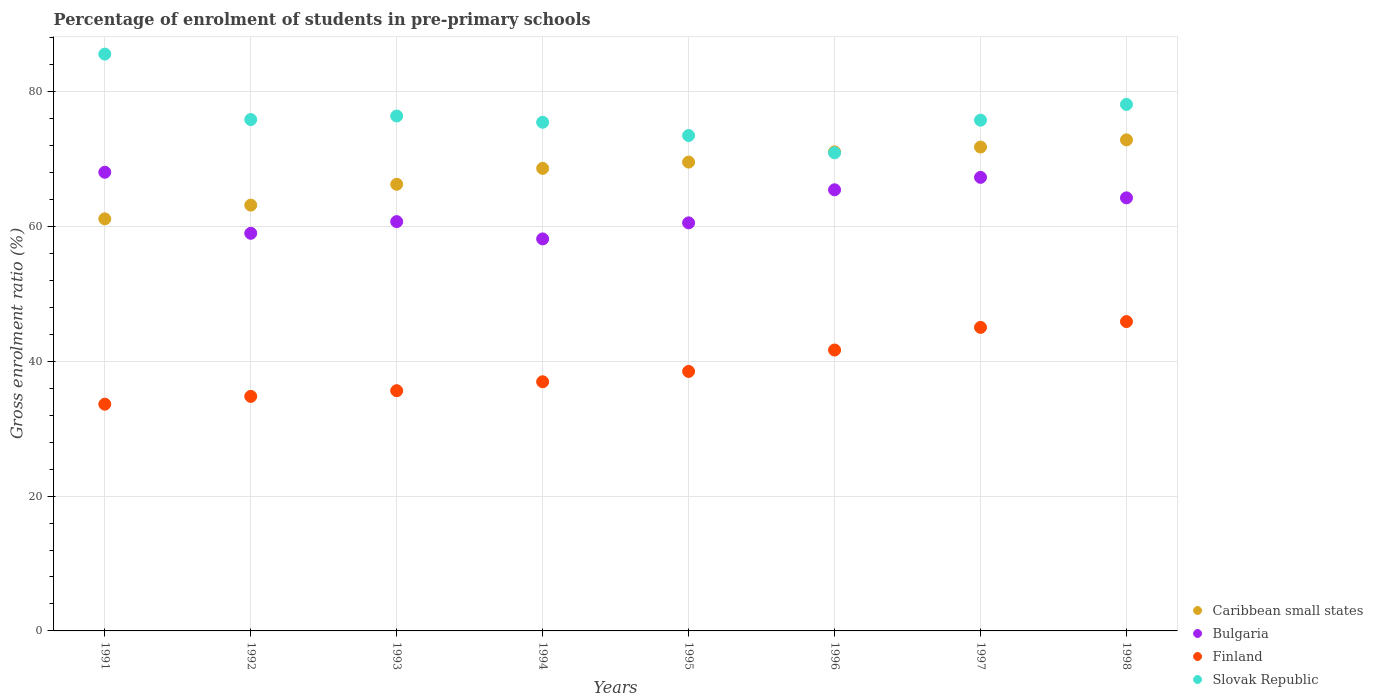How many different coloured dotlines are there?
Offer a very short reply. 4. What is the percentage of students enrolled in pre-primary schools in Finland in 1995?
Ensure brevity in your answer.  38.49. Across all years, what is the maximum percentage of students enrolled in pre-primary schools in Bulgaria?
Keep it short and to the point. 68.03. Across all years, what is the minimum percentage of students enrolled in pre-primary schools in Caribbean small states?
Make the answer very short. 61.12. In which year was the percentage of students enrolled in pre-primary schools in Slovak Republic minimum?
Your answer should be very brief. 1996. What is the total percentage of students enrolled in pre-primary schools in Slovak Republic in the graph?
Make the answer very short. 611.43. What is the difference between the percentage of students enrolled in pre-primary schools in Finland in 1993 and that in 1998?
Provide a short and direct response. -10.25. What is the difference between the percentage of students enrolled in pre-primary schools in Finland in 1993 and the percentage of students enrolled in pre-primary schools in Bulgaria in 1997?
Make the answer very short. -31.64. What is the average percentage of students enrolled in pre-primary schools in Finland per year?
Make the answer very short. 39. In the year 1998, what is the difference between the percentage of students enrolled in pre-primary schools in Caribbean small states and percentage of students enrolled in pre-primary schools in Finland?
Offer a terse response. 26.95. In how many years, is the percentage of students enrolled in pre-primary schools in Finland greater than 36 %?
Give a very brief answer. 5. What is the ratio of the percentage of students enrolled in pre-primary schools in Slovak Republic in 1993 to that in 1995?
Offer a very short reply. 1.04. Is the percentage of students enrolled in pre-primary schools in Bulgaria in 1991 less than that in 1995?
Your answer should be compact. No. What is the difference between the highest and the second highest percentage of students enrolled in pre-primary schools in Caribbean small states?
Ensure brevity in your answer.  1.07. What is the difference between the highest and the lowest percentage of students enrolled in pre-primary schools in Bulgaria?
Ensure brevity in your answer.  9.89. In how many years, is the percentage of students enrolled in pre-primary schools in Slovak Republic greater than the average percentage of students enrolled in pre-primary schools in Slovak Republic taken over all years?
Your answer should be compact. 2. Is the sum of the percentage of students enrolled in pre-primary schools in Bulgaria in 1991 and 1993 greater than the maximum percentage of students enrolled in pre-primary schools in Finland across all years?
Provide a short and direct response. Yes. Is the percentage of students enrolled in pre-primary schools in Finland strictly greater than the percentage of students enrolled in pre-primary schools in Bulgaria over the years?
Offer a very short reply. No. How many dotlines are there?
Provide a succinct answer. 4. How many years are there in the graph?
Offer a very short reply. 8. Does the graph contain any zero values?
Your response must be concise. No. How many legend labels are there?
Provide a succinct answer. 4. What is the title of the graph?
Offer a terse response. Percentage of enrolment of students in pre-primary schools. Does "Angola" appear as one of the legend labels in the graph?
Offer a terse response. No. What is the Gross enrolment ratio (%) in Caribbean small states in 1991?
Ensure brevity in your answer.  61.12. What is the Gross enrolment ratio (%) in Bulgaria in 1991?
Provide a succinct answer. 68.03. What is the Gross enrolment ratio (%) of Finland in 1991?
Ensure brevity in your answer.  33.63. What is the Gross enrolment ratio (%) in Slovak Republic in 1991?
Give a very brief answer. 85.55. What is the Gross enrolment ratio (%) in Caribbean small states in 1992?
Your response must be concise. 63.15. What is the Gross enrolment ratio (%) in Bulgaria in 1992?
Your answer should be compact. 58.97. What is the Gross enrolment ratio (%) in Finland in 1992?
Make the answer very short. 34.78. What is the Gross enrolment ratio (%) in Slovak Republic in 1992?
Ensure brevity in your answer.  75.84. What is the Gross enrolment ratio (%) in Caribbean small states in 1993?
Offer a terse response. 66.24. What is the Gross enrolment ratio (%) in Bulgaria in 1993?
Ensure brevity in your answer.  60.7. What is the Gross enrolment ratio (%) in Finland in 1993?
Ensure brevity in your answer.  35.63. What is the Gross enrolment ratio (%) in Slovak Republic in 1993?
Your answer should be compact. 76.37. What is the Gross enrolment ratio (%) in Caribbean small states in 1994?
Provide a succinct answer. 68.6. What is the Gross enrolment ratio (%) of Bulgaria in 1994?
Offer a very short reply. 58.14. What is the Gross enrolment ratio (%) in Finland in 1994?
Give a very brief answer. 36.95. What is the Gross enrolment ratio (%) in Slovak Republic in 1994?
Provide a succinct answer. 75.44. What is the Gross enrolment ratio (%) of Caribbean small states in 1995?
Your answer should be compact. 69.53. What is the Gross enrolment ratio (%) in Bulgaria in 1995?
Provide a succinct answer. 60.52. What is the Gross enrolment ratio (%) of Finland in 1995?
Make the answer very short. 38.49. What is the Gross enrolment ratio (%) in Slovak Republic in 1995?
Offer a very short reply. 73.47. What is the Gross enrolment ratio (%) in Caribbean small states in 1996?
Ensure brevity in your answer.  71.05. What is the Gross enrolment ratio (%) in Bulgaria in 1996?
Your answer should be compact. 65.42. What is the Gross enrolment ratio (%) in Finland in 1996?
Ensure brevity in your answer.  41.66. What is the Gross enrolment ratio (%) of Slovak Republic in 1996?
Make the answer very short. 70.91. What is the Gross enrolment ratio (%) in Caribbean small states in 1997?
Keep it short and to the point. 71.76. What is the Gross enrolment ratio (%) of Bulgaria in 1997?
Provide a succinct answer. 67.27. What is the Gross enrolment ratio (%) in Finland in 1997?
Your response must be concise. 45.02. What is the Gross enrolment ratio (%) in Slovak Republic in 1997?
Keep it short and to the point. 75.75. What is the Gross enrolment ratio (%) in Caribbean small states in 1998?
Give a very brief answer. 72.83. What is the Gross enrolment ratio (%) of Bulgaria in 1998?
Make the answer very short. 64.23. What is the Gross enrolment ratio (%) of Finland in 1998?
Your answer should be compact. 45.88. What is the Gross enrolment ratio (%) of Slovak Republic in 1998?
Your answer should be compact. 78.09. Across all years, what is the maximum Gross enrolment ratio (%) in Caribbean small states?
Give a very brief answer. 72.83. Across all years, what is the maximum Gross enrolment ratio (%) of Bulgaria?
Provide a succinct answer. 68.03. Across all years, what is the maximum Gross enrolment ratio (%) of Finland?
Provide a succinct answer. 45.88. Across all years, what is the maximum Gross enrolment ratio (%) of Slovak Republic?
Your response must be concise. 85.55. Across all years, what is the minimum Gross enrolment ratio (%) in Caribbean small states?
Offer a terse response. 61.12. Across all years, what is the minimum Gross enrolment ratio (%) of Bulgaria?
Ensure brevity in your answer.  58.14. Across all years, what is the minimum Gross enrolment ratio (%) of Finland?
Offer a very short reply. 33.63. Across all years, what is the minimum Gross enrolment ratio (%) in Slovak Republic?
Ensure brevity in your answer.  70.91. What is the total Gross enrolment ratio (%) of Caribbean small states in the graph?
Ensure brevity in your answer.  544.28. What is the total Gross enrolment ratio (%) of Bulgaria in the graph?
Give a very brief answer. 503.28. What is the total Gross enrolment ratio (%) of Finland in the graph?
Keep it short and to the point. 312.04. What is the total Gross enrolment ratio (%) in Slovak Republic in the graph?
Provide a short and direct response. 611.43. What is the difference between the Gross enrolment ratio (%) in Caribbean small states in 1991 and that in 1992?
Ensure brevity in your answer.  -2.04. What is the difference between the Gross enrolment ratio (%) of Bulgaria in 1991 and that in 1992?
Provide a succinct answer. 9.05. What is the difference between the Gross enrolment ratio (%) of Finland in 1991 and that in 1992?
Your answer should be very brief. -1.16. What is the difference between the Gross enrolment ratio (%) of Slovak Republic in 1991 and that in 1992?
Offer a terse response. 9.71. What is the difference between the Gross enrolment ratio (%) of Caribbean small states in 1991 and that in 1993?
Provide a short and direct response. -5.13. What is the difference between the Gross enrolment ratio (%) of Bulgaria in 1991 and that in 1993?
Offer a terse response. 7.32. What is the difference between the Gross enrolment ratio (%) in Finland in 1991 and that in 1993?
Provide a succinct answer. -2. What is the difference between the Gross enrolment ratio (%) of Slovak Republic in 1991 and that in 1993?
Make the answer very short. 9.18. What is the difference between the Gross enrolment ratio (%) in Caribbean small states in 1991 and that in 1994?
Provide a short and direct response. -7.48. What is the difference between the Gross enrolment ratio (%) in Bulgaria in 1991 and that in 1994?
Make the answer very short. 9.89. What is the difference between the Gross enrolment ratio (%) in Finland in 1991 and that in 1994?
Offer a terse response. -3.32. What is the difference between the Gross enrolment ratio (%) of Slovak Republic in 1991 and that in 1994?
Your answer should be very brief. 10.11. What is the difference between the Gross enrolment ratio (%) in Caribbean small states in 1991 and that in 1995?
Keep it short and to the point. -8.42. What is the difference between the Gross enrolment ratio (%) of Bulgaria in 1991 and that in 1995?
Provide a succinct answer. 7.51. What is the difference between the Gross enrolment ratio (%) of Finland in 1991 and that in 1995?
Offer a terse response. -4.86. What is the difference between the Gross enrolment ratio (%) of Slovak Republic in 1991 and that in 1995?
Give a very brief answer. 12.08. What is the difference between the Gross enrolment ratio (%) in Caribbean small states in 1991 and that in 1996?
Keep it short and to the point. -9.93. What is the difference between the Gross enrolment ratio (%) in Bulgaria in 1991 and that in 1996?
Provide a short and direct response. 2.6. What is the difference between the Gross enrolment ratio (%) of Finland in 1991 and that in 1996?
Your answer should be very brief. -8.03. What is the difference between the Gross enrolment ratio (%) in Slovak Republic in 1991 and that in 1996?
Offer a terse response. 14.64. What is the difference between the Gross enrolment ratio (%) of Caribbean small states in 1991 and that in 1997?
Keep it short and to the point. -10.65. What is the difference between the Gross enrolment ratio (%) of Bulgaria in 1991 and that in 1997?
Offer a terse response. 0.76. What is the difference between the Gross enrolment ratio (%) in Finland in 1991 and that in 1997?
Provide a short and direct response. -11.39. What is the difference between the Gross enrolment ratio (%) of Slovak Republic in 1991 and that in 1997?
Your response must be concise. 9.8. What is the difference between the Gross enrolment ratio (%) in Caribbean small states in 1991 and that in 1998?
Provide a succinct answer. -11.71. What is the difference between the Gross enrolment ratio (%) in Bulgaria in 1991 and that in 1998?
Your answer should be compact. 3.8. What is the difference between the Gross enrolment ratio (%) of Finland in 1991 and that in 1998?
Give a very brief answer. -12.25. What is the difference between the Gross enrolment ratio (%) in Slovak Republic in 1991 and that in 1998?
Offer a terse response. 7.47. What is the difference between the Gross enrolment ratio (%) of Caribbean small states in 1992 and that in 1993?
Offer a terse response. -3.09. What is the difference between the Gross enrolment ratio (%) of Bulgaria in 1992 and that in 1993?
Make the answer very short. -1.73. What is the difference between the Gross enrolment ratio (%) of Finland in 1992 and that in 1993?
Make the answer very short. -0.84. What is the difference between the Gross enrolment ratio (%) of Slovak Republic in 1992 and that in 1993?
Make the answer very short. -0.53. What is the difference between the Gross enrolment ratio (%) in Caribbean small states in 1992 and that in 1994?
Offer a very short reply. -5.45. What is the difference between the Gross enrolment ratio (%) of Bulgaria in 1992 and that in 1994?
Your response must be concise. 0.83. What is the difference between the Gross enrolment ratio (%) of Finland in 1992 and that in 1994?
Ensure brevity in your answer.  -2.17. What is the difference between the Gross enrolment ratio (%) of Slovak Republic in 1992 and that in 1994?
Your answer should be compact. 0.4. What is the difference between the Gross enrolment ratio (%) in Caribbean small states in 1992 and that in 1995?
Your answer should be very brief. -6.38. What is the difference between the Gross enrolment ratio (%) of Bulgaria in 1992 and that in 1995?
Your answer should be compact. -1.55. What is the difference between the Gross enrolment ratio (%) of Finland in 1992 and that in 1995?
Offer a very short reply. -3.7. What is the difference between the Gross enrolment ratio (%) in Slovak Republic in 1992 and that in 1995?
Ensure brevity in your answer.  2.37. What is the difference between the Gross enrolment ratio (%) in Caribbean small states in 1992 and that in 1996?
Keep it short and to the point. -7.9. What is the difference between the Gross enrolment ratio (%) of Bulgaria in 1992 and that in 1996?
Your response must be concise. -6.45. What is the difference between the Gross enrolment ratio (%) of Finland in 1992 and that in 1996?
Provide a short and direct response. -6.88. What is the difference between the Gross enrolment ratio (%) of Slovak Republic in 1992 and that in 1996?
Keep it short and to the point. 4.93. What is the difference between the Gross enrolment ratio (%) in Caribbean small states in 1992 and that in 1997?
Give a very brief answer. -8.61. What is the difference between the Gross enrolment ratio (%) in Bulgaria in 1992 and that in 1997?
Make the answer very short. -8.3. What is the difference between the Gross enrolment ratio (%) of Finland in 1992 and that in 1997?
Make the answer very short. -10.23. What is the difference between the Gross enrolment ratio (%) in Slovak Republic in 1992 and that in 1997?
Your response must be concise. 0.09. What is the difference between the Gross enrolment ratio (%) of Caribbean small states in 1992 and that in 1998?
Your answer should be very brief. -9.68. What is the difference between the Gross enrolment ratio (%) of Bulgaria in 1992 and that in 1998?
Your answer should be very brief. -5.26. What is the difference between the Gross enrolment ratio (%) of Finland in 1992 and that in 1998?
Provide a short and direct response. -11.09. What is the difference between the Gross enrolment ratio (%) in Slovak Republic in 1992 and that in 1998?
Provide a succinct answer. -2.25. What is the difference between the Gross enrolment ratio (%) of Caribbean small states in 1993 and that in 1994?
Provide a short and direct response. -2.36. What is the difference between the Gross enrolment ratio (%) of Bulgaria in 1993 and that in 1994?
Keep it short and to the point. 2.57. What is the difference between the Gross enrolment ratio (%) in Finland in 1993 and that in 1994?
Offer a terse response. -1.32. What is the difference between the Gross enrolment ratio (%) in Caribbean small states in 1993 and that in 1995?
Provide a succinct answer. -3.29. What is the difference between the Gross enrolment ratio (%) in Bulgaria in 1993 and that in 1995?
Provide a succinct answer. 0.18. What is the difference between the Gross enrolment ratio (%) of Finland in 1993 and that in 1995?
Offer a very short reply. -2.86. What is the difference between the Gross enrolment ratio (%) of Slovak Republic in 1993 and that in 1995?
Provide a short and direct response. 2.89. What is the difference between the Gross enrolment ratio (%) of Caribbean small states in 1993 and that in 1996?
Ensure brevity in your answer.  -4.81. What is the difference between the Gross enrolment ratio (%) of Bulgaria in 1993 and that in 1996?
Your answer should be compact. -4.72. What is the difference between the Gross enrolment ratio (%) in Finland in 1993 and that in 1996?
Your response must be concise. -6.03. What is the difference between the Gross enrolment ratio (%) in Slovak Republic in 1993 and that in 1996?
Your answer should be compact. 5.46. What is the difference between the Gross enrolment ratio (%) of Caribbean small states in 1993 and that in 1997?
Give a very brief answer. -5.52. What is the difference between the Gross enrolment ratio (%) of Bulgaria in 1993 and that in 1997?
Provide a short and direct response. -6.56. What is the difference between the Gross enrolment ratio (%) of Finland in 1993 and that in 1997?
Offer a terse response. -9.39. What is the difference between the Gross enrolment ratio (%) in Slovak Republic in 1993 and that in 1997?
Give a very brief answer. 0.62. What is the difference between the Gross enrolment ratio (%) of Caribbean small states in 1993 and that in 1998?
Ensure brevity in your answer.  -6.59. What is the difference between the Gross enrolment ratio (%) in Bulgaria in 1993 and that in 1998?
Keep it short and to the point. -3.52. What is the difference between the Gross enrolment ratio (%) of Finland in 1993 and that in 1998?
Your answer should be compact. -10.25. What is the difference between the Gross enrolment ratio (%) of Slovak Republic in 1993 and that in 1998?
Your answer should be very brief. -1.72. What is the difference between the Gross enrolment ratio (%) of Caribbean small states in 1994 and that in 1995?
Your answer should be very brief. -0.93. What is the difference between the Gross enrolment ratio (%) of Bulgaria in 1994 and that in 1995?
Your response must be concise. -2.38. What is the difference between the Gross enrolment ratio (%) in Finland in 1994 and that in 1995?
Offer a very short reply. -1.54. What is the difference between the Gross enrolment ratio (%) of Slovak Republic in 1994 and that in 1995?
Make the answer very short. 1.96. What is the difference between the Gross enrolment ratio (%) in Caribbean small states in 1994 and that in 1996?
Your response must be concise. -2.45. What is the difference between the Gross enrolment ratio (%) of Bulgaria in 1994 and that in 1996?
Ensure brevity in your answer.  -7.28. What is the difference between the Gross enrolment ratio (%) in Finland in 1994 and that in 1996?
Give a very brief answer. -4.71. What is the difference between the Gross enrolment ratio (%) of Slovak Republic in 1994 and that in 1996?
Provide a succinct answer. 4.53. What is the difference between the Gross enrolment ratio (%) of Caribbean small states in 1994 and that in 1997?
Offer a terse response. -3.16. What is the difference between the Gross enrolment ratio (%) of Bulgaria in 1994 and that in 1997?
Give a very brief answer. -9.13. What is the difference between the Gross enrolment ratio (%) of Finland in 1994 and that in 1997?
Provide a short and direct response. -8.07. What is the difference between the Gross enrolment ratio (%) of Slovak Republic in 1994 and that in 1997?
Offer a terse response. -0.31. What is the difference between the Gross enrolment ratio (%) in Caribbean small states in 1994 and that in 1998?
Provide a short and direct response. -4.23. What is the difference between the Gross enrolment ratio (%) of Bulgaria in 1994 and that in 1998?
Give a very brief answer. -6.09. What is the difference between the Gross enrolment ratio (%) of Finland in 1994 and that in 1998?
Give a very brief answer. -8.93. What is the difference between the Gross enrolment ratio (%) in Slovak Republic in 1994 and that in 1998?
Ensure brevity in your answer.  -2.65. What is the difference between the Gross enrolment ratio (%) of Caribbean small states in 1995 and that in 1996?
Provide a succinct answer. -1.51. What is the difference between the Gross enrolment ratio (%) of Bulgaria in 1995 and that in 1996?
Give a very brief answer. -4.9. What is the difference between the Gross enrolment ratio (%) in Finland in 1995 and that in 1996?
Ensure brevity in your answer.  -3.17. What is the difference between the Gross enrolment ratio (%) of Slovak Republic in 1995 and that in 1996?
Your answer should be compact. 2.56. What is the difference between the Gross enrolment ratio (%) of Caribbean small states in 1995 and that in 1997?
Offer a terse response. -2.23. What is the difference between the Gross enrolment ratio (%) of Bulgaria in 1995 and that in 1997?
Your answer should be very brief. -6.75. What is the difference between the Gross enrolment ratio (%) of Finland in 1995 and that in 1997?
Your answer should be very brief. -6.53. What is the difference between the Gross enrolment ratio (%) of Slovak Republic in 1995 and that in 1997?
Keep it short and to the point. -2.28. What is the difference between the Gross enrolment ratio (%) of Caribbean small states in 1995 and that in 1998?
Your answer should be compact. -3.29. What is the difference between the Gross enrolment ratio (%) in Bulgaria in 1995 and that in 1998?
Provide a short and direct response. -3.71. What is the difference between the Gross enrolment ratio (%) in Finland in 1995 and that in 1998?
Provide a succinct answer. -7.39. What is the difference between the Gross enrolment ratio (%) of Slovak Republic in 1995 and that in 1998?
Provide a short and direct response. -4.61. What is the difference between the Gross enrolment ratio (%) in Caribbean small states in 1996 and that in 1997?
Offer a very short reply. -0.72. What is the difference between the Gross enrolment ratio (%) of Bulgaria in 1996 and that in 1997?
Provide a short and direct response. -1.85. What is the difference between the Gross enrolment ratio (%) in Finland in 1996 and that in 1997?
Your response must be concise. -3.36. What is the difference between the Gross enrolment ratio (%) in Slovak Republic in 1996 and that in 1997?
Your answer should be compact. -4.84. What is the difference between the Gross enrolment ratio (%) in Caribbean small states in 1996 and that in 1998?
Give a very brief answer. -1.78. What is the difference between the Gross enrolment ratio (%) in Bulgaria in 1996 and that in 1998?
Give a very brief answer. 1.2. What is the difference between the Gross enrolment ratio (%) in Finland in 1996 and that in 1998?
Keep it short and to the point. -4.22. What is the difference between the Gross enrolment ratio (%) in Slovak Republic in 1996 and that in 1998?
Your answer should be compact. -7.18. What is the difference between the Gross enrolment ratio (%) of Caribbean small states in 1997 and that in 1998?
Keep it short and to the point. -1.07. What is the difference between the Gross enrolment ratio (%) of Bulgaria in 1997 and that in 1998?
Provide a short and direct response. 3.04. What is the difference between the Gross enrolment ratio (%) of Finland in 1997 and that in 1998?
Keep it short and to the point. -0.86. What is the difference between the Gross enrolment ratio (%) of Slovak Republic in 1997 and that in 1998?
Your answer should be compact. -2.34. What is the difference between the Gross enrolment ratio (%) of Caribbean small states in 1991 and the Gross enrolment ratio (%) of Bulgaria in 1992?
Provide a short and direct response. 2.14. What is the difference between the Gross enrolment ratio (%) in Caribbean small states in 1991 and the Gross enrolment ratio (%) in Finland in 1992?
Ensure brevity in your answer.  26.33. What is the difference between the Gross enrolment ratio (%) of Caribbean small states in 1991 and the Gross enrolment ratio (%) of Slovak Republic in 1992?
Your answer should be compact. -14.73. What is the difference between the Gross enrolment ratio (%) in Bulgaria in 1991 and the Gross enrolment ratio (%) in Finland in 1992?
Offer a terse response. 33.24. What is the difference between the Gross enrolment ratio (%) of Bulgaria in 1991 and the Gross enrolment ratio (%) of Slovak Republic in 1992?
Provide a succinct answer. -7.82. What is the difference between the Gross enrolment ratio (%) in Finland in 1991 and the Gross enrolment ratio (%) in Slovak Republic in 1992?
Keep it short and to the point. -42.21. What is the difference between the Gross enrolment ratio (%) in Caribbean small states in 1991 and the Gross enrolment ratio (%) in Bulgaria in 1993?
Provide a succinct answer. 0.41. What is the difference between the Gross enrolment ratio (%) of Caribbean small states in 1991 and the Gross enrolment ratio (%) of Finland in 1993?
Keep it short and to the point. 25.49. What is the difference between the Gross enrolment ratio (%) of Caribbean small states in 1991 and the Gross enrolment ratio (%) of Slovak Republic in 1993?
Offer a very short reply. -15.25. What is the difference between the Gross enrolment ratio (%) in Bulgaria in 1991 and the Gross enrolment ratio (%) in Finland in 1993?
Provide a succinct answer. 32.4. What is the difference between the Gross enrolment ratio (%) of Bulgaria in 1991 and the Gross enrolment ratio (%) of Slovak Republic in 1993?
Your answer should be very brief. -8.34. What is the difference between the Gross enrolment ratio (%) in Finland in 1991 and the Gross enrolment ratio (%) in Slovak Republic in 1993?
Provide a short and direct response. -42.74. What is the difference between the Gross enrolment ratio (%) of Caribbean small states in 1991 and the Gross enrolment ratio (%) of Bulgaria in 1994?
Your answer should be very brief. 2.98. What is the difference between the Gross enrolment ratio (%) in Caribbean small states in 1991 and the Gross enrolment ratio (%) in Finland in 1994?
Your answer should be very brief. 24.16. What is the difference between the Gross enrolment ratio (%) in Caribbean small states in 1991 and the Gross enrolment ratio (%) in Slovak Republic in 1994?
Give a very brief answer. -14.32. What is the difference between the Gross enrolment ratio (%) of Bulgaria in 1991 and the Gross enrolment ratio (%) of Finland in 1994?
Keep it short and to the point. 31.07. What is the difference between the Gross enrolment ratio (%) of Bulgaria in 1991 and the Gross enrolment ratio (%) of Slovak Republic in 1994?
Offer a terse response. -7.41. What is the difference between the Gross enrolment ratio (%) in Finland in 1991 and the Gross enrolment ratio (%) in Slovak Republic in 1994?
Your response must be concise. -41.81. What is the difference between the Gross enrolment ratio (%) in Caribbean small states in 1991 and the Gross enrolment ratio (%) in Bulgaria in 1995?
Give a very brief answer. 0.6. What is the difference between the Gross enrolment ratio (%) of Caribbean small states in 1991 and the Gross enrolment ratio (%) of Finland in 1995?
Provide a short and direct response. 22.63. What is the difference between the Gross enrolment ratio (%) of Caribbean small states in 1991 and the Gross enrolment ratio (%) of Slovak Republic in 1995?
Keep it short and to the point. -12.36. What is the difference between the Gross enrolment ratio (%) of Bulgaria in 1991 and the Gross enrolment ratio (%) of Finland in 1995?
Keep it short and to the point. 29.54. What is the difference between the Gross enrolment ratio (%) of Bulgaria in 1991 and the Gross enrolment ratio (%) of Slovak Republic in 1995?
Offer a terse response. -5.45. What is the difference between the Gross enrolment ratio (%) of Finland in 1991 and the Gross enrolment ratio (%) of Slovak Republic in 1995?
Ensure brevity in your answer.  -39.85. What is the difference between the Gross enrolment ratio (%) of Caribbean small states in 1991 and the Gross enrolment ratio (%) of Bulgaria in 1996?
Your answer should be very brief. -4.31. What is the difference between the Gross enrolment ratio (%) in Caribbean small states in 1991 and the Gross enrolment ratio (%) in Finland in 1996?
Make the answer very short. 19.46. What is the difference between the Gross enrolment ratio (%) in Caribbean small states in 1991 and the Gross enrolment ratio (%) in Slovak Republic in 1996?
Give a very brief answer. -9.79. What is the difference between the Gross enrolment ratio (%) in Bulgaria in 1991 and the Gross enrolment ratio (%) in Finland in 1996?
Give a very brief answer. 26.37. What is the difference between the Gross enrolment ratio (%) of Bulgaria in 1991 and the Gross enrolment ratio (%) of Slovak Republic in 1996?
Your response must be concise. -2.88. What is the difference between the Gross enrolment ratio (%) of Finland in 1991 and the Gross enrolment ratio (%) of Slovak Republic in 1996?
Keep it short and to the point. -37.28. What is the difference between the Gross enrolment ratio (%) of Caribbean small states in 1991 and the Gross enrolment ratio (%) of Bulgaria in 1997?
Provide a short and direct response. -6.15. What is the difference between the Gross enrolment ratio (%) in Caribbean small states in 1991 and the Gross enrolment ratio (%) in Finland in 1997?
Provide a succinct answer. 16.1. What is the difference between the Gross enrolment ratio (%) of Caribbean small states in 1991 and the Gross enrolment ratio (%) of Slovak Republic in 1997?
Offer a very short reply. -14.64. What is the difference between the Gross enrolment ratio (%) of Bulgaria in 1991 and the Gross enrolment ratio (%) of Finland in 1997?
Your answer should be compact. 23.01. What is the difference between the Gross enrolment ratio (%) of Bulgaria in 1991 and the Gross enrolment ratio (%) of Slovak Republic in 1997?
Make the answer very short. -7.72. What is the difference between the Gross enrolment ratio (%) in Finland in 1991 and the Gross enrolment ratio (%) in Slovak Republic in 1997?
Provide a short and direct response. -42.12. What is the difference between the Gross enrolment ratio (%) in Caribbean small states in 1991 and the Gross enrolment ratio (%) in Bulgaria in 1998?
Offer a very short reply. -3.11. What is the difference between the Gross enrolment ratio (%) of Caribbean small states in 1991 and the Gross enrolment ratio (%) of Finland in 1998?
Your answer should be very brief. 15.24. What is the difference between the Gross enrolment ratio (%) in Caribbean small states in 1991 and the Gross enrolment ratio (%) in Slovak Republic in 1998?
Your response must be concise. -16.97. What is the difference between the Gross enrolment ratio (%) in Bulgaria in 1991 and the Gross enrolment ratio (%) in Finland in 1998?
Keep it short and to the point. 22.15. What is the difference between the Gross enrolment ratio (%) in Bulgaria in 1991 and the Gross enrolment ratio (%) in Slovak Republic in 1998?
Offer a terse response. -10.06. What is the difference between the Gross enrolment ratio (%) in Finland in 1991 and the Gross enrolment ratio (%) in Slovak Republic in 1998?
Provide a short and direct response. -44.46. What is the difference between the Gross enrolment ratio (%) of Caribbean small states in 1992 and the Gross enrolment ratio (%) of Bulgaria in 1993?
Keep it short and to the point. 2.45. What is the difference between the Gross enrolment ratio (%) in Caribbean small states in 1992 and the Gross enrolment ratio (%) in Finland in 1993?
Offer a very short reply. 27.52. What is the difference between the Gross enrolment ratio (%) of Caribbean small states in 1992 and the Gross enrolment ratio (%) of Slovak Republic in 1993?
Provide a short and direct response. -13.22. What is the difference between the Gross enrolment ratio (%) in Bulgaria in 1992 and the Gross enrolment ratio (%) in Finland in 1993?
Provide a short and direct response. 23.34. What is the difference between the Gross enrolment ratio (%) in Bulgaria in 1992 and the Gross enrolment ratio (%) in Slovak Republic in 1993?
Keep it short and to the point. -17.4. What is the difference between the Gross enrolment ratio (%) in Finland in 1992 and the Gross enrolment ratio (%) in Slovak Republic in 1993?
Make the answer very short. -41.58. What is the difference between the Gross enrolment ratio (%) of Caribbean small states in 1992 and the Gross enrolment ratio (%) of Bulgaria in 1994?
Offer a very short reply. 5.01. What is the difference between the Gross enrolment ratio (%) in Caribbean small states in 1992 and the Gross enrolment ratio (%) in Finland in 1994?
Your answer should be compact. 26.2. What is the difference between the Gross enrolment ratio (%) of Caribbean small states in 1992 and the Gross enrolment ratio (%) of Slovak Republic in 1994?
Make the answer very short. -12.29. What is the difference between the Gross enrolment ratio (%) of Bulgaria in 1992 and the Gross enrolment ratio (%) of Finland in 1994?
Your answer should be compact. 22.02. What is the difference between the Gross enrolment ratio (%) of Bulgaria in 1992 and the Gross enrolment ratio (%) of Slovak Republic in 1994?
Ensure brevity in your answer.  -16.47. What is the difference between the Gross enrolment ratio (%) in Finland in 1992 and the Gross enrolment ratio (%) in Slovak Republic in 1994?
Provide a succinct answer. -40.65. What is the difference between the Gross enrolment ratio (%) in Caribbean small states in 1992 and the Gross enrolment ratio (%) in Bulgaria in 1995?
Provide a succinct answer. 2.63. What is the difference between the Gross enrolment ratio (%) of Caribbean small states in 1992 and the Gross enrolment ratio (%) of Finland in 1995?
Make the answer very short. 24.66. What is the difference between the Gross enrolment ratio (%) of Caribbean small states in 1992 and the Gross enrolment ratio (%) of Slovak Republic in 1995?
Offer a very short reply. -10.32. What is the difference between the Gross enrolment ratio (%) of Bulgaria in 1992 and the Gross enrolment ratio (%) of Finland in 1995?
Ensure brevity in your answer.  20.48. What is the difference between the Gross enrolment ratio (%) of Bulgaria in 1992 and the Gross enrolment ratio (%) of Slovak Republic in 1995?
Offer a terse response. -14.5. What is the difference between the Gross enrolment ratio (%) in Finland in 1992 and the Gross enrolment ratio (%) in Slovak Republic in 1995?
Make the answer very short. -38.69. What is the difference between the Gross enrolment ratio (%) of Caribbean small states in 1992 and the Gross enrolment ratio (%) of Bulgaria in 1996?
Ensure brevity in your answer.  -2.27. What is the difference between the Gross enrolment ratio (%) of Caribbean small states in 1992 and the Gross enrolment ratio (%) of Finland in 1996?
Provide a succinct answer. 21.49. What is the difference between the Gross enrolment ratio (%) of Caribbean small states in 1992 and the Gross enrolment ratio (%) of Slovak Republic in 1996?
Your answer should be very brief. -7.76. What is the difference between the Gross enrolment ratio (%) of Bulgaria in 1992 and the Gross enrolment ratio (%) of Finland in 1996?
Offer a very short reply. 17.31. What is the difference between the Gross enrolment ratio (%) of Bulgaria in 1992 and the Gross enrolment ratio (%) of Slovak Republic in 1996?
Your answer should be very brief. -11.94. What is the difference between the Gross enrolment ratio (%) in Finland in 1992 and the Gross enrolment ratio (%) in Slovak Republic in 1996?
Your answer should be compact. -36.13. What is the difference between the Gross enrolment ratio (%) of Caribbean small states in 1992 and the Gross enrolment ratio (%) of Bulgaria in 1997?
Ensure brevity in your answer.  -4.12. What is the difference between the Gross enrolment ratio (%) of Caribbean small states in 1992 and the Gross enrolment ratio (%) of Finland in 1997?
Offer a terse response. 18.13. What is the difference between the Gross enrolment ratio (%) of Caribbean small states in 1992 and the Gross enrolment ratio (%) of Slovak Republic in 1997?
Your answer should be compact. -12.6. What is the difference between the Gross enrolment ratio (%) of Bulgaria in 1992 and the Gross enrolment ratio (%) of Finland in 1997?
Your answer should be compact. 13.95. What is the difference between the Gross enrolment ratio (%) in Bulgaria in 1992 and the Gross enrolment ratio (%) in Slovak Republic in 1997?
Offer a very short reply. -16.78. What is the difference between the Gross enrolment ratio (%) in Finland in 1992 and the Gross enrolment ratio (%) in Slovak Republic in 1997?
Make the answer very short. -40.97. What is the difference between the Gross enrolment ratio (%) of Caribbean small states in 1992 and the Gross enrolment ratio (%) of Bulgaria in 1998?
Your answer should be compact. -1.08. What is the difference between the Gross enrolment ratio (%) in Caribbean small states in 1992 and the Gross enrolment ratio (%) in Finland in 1998?
Keep it short and to the point. 17.27. What is the difference between the Gross enrolment ratio (%) of Caribbean small states in 1992 and the Gross enrolment ratio (%) of Slovak Republic in 1998?
Offer a very short reply. -14.94. What is the difference between the Gross enrolment ratio (%) of Bulgaria in 1992 and the Gross enrolment ratio (%) of Finland in 1998?
Keep it short and to the point. 13.09. What is the difference between the Gross enrolment ratio (%) of Bulgaria in 1992 and the Gross enrolment ratio (%) of Slovak Republic in 1998?
Offer a terse response. -19.12. What is the difference between the Gross enrolment ratio (%) of Finland in 1992 and the Gross enrolment ratio (%) of Slovak Republic in 1998?
Make the answer very short. -43.3. What is the difference between the Gross enrolment ratio (%) in Caribbean small states in 1993 and the Gross enrolment ratio (%) in Bulgaria in 1994?
Provide a succinct answer. 8.1. What is the difference between the Gross enrolment ratio (%) of Caribbean small states in 1993 and the Gross enrolment ratio (%) of Finland in 1994?
Provide a short and direct response. 29.29. What is the difference between the Gross enrolment ratio (%) in Caribbean small states in 1993 and the Gross enrolment ratio (%) in Slovak Republic in 1994?
Your answer should be compact. -9.2. What is the difference between the Gross enrolment ratio (%) of Bulgaria in 1993 and the Gross enrolment ratio (%) of Finland in 1994?
Provide a short and direct response. 23.75. What is the difference between the Gross enrolment ratio (%) of Bulgaria in 1993 and the Gross enrolment ratio (%) of Slovak Republic in 1994?
Make the answer very short. -14.73. What is the difference between the Gross enrolment ratio (%) of Finland in 1993 and the Gross enrolment ratio (%) of Slovak Republic in 1994?
Your answer should be compact. -39.81. What is the difference between the Gross enrolment ratio (%) of Caribbean small states in 1993 and the Gross enrolment ratio (%) of Bulgaria in 1995?
Make the answer very short. 5.72. What is the difference between the Gross enrolment ratio (%) in Caribbean small states in 1993 and the Gross enrolment ratio (%) in Finland in 1995?
Keep it short and to the point. 27.75. What is the difference between the Gross enrolment ratio (%) in Caribbean small states in 1993 and the Gross enrolment ratio (%) in Slovak Republic in 1995?
Make the answer very short. -7.23. What is the difference between the Gross enrolment ratio (%) of Bulgaria in 1993 and the Gross enrolment ratio (%) of Finland in 1995?
Your answer should be very brief. 22.22. What is the difference between the Gross enrolment ratio (%) in Bulgaria in 1993 and the Gross enrolment ratio (%) in Slovak Republic in 1995?
Keep it short and to the point. -12.77. What is the difference between the Gross enrolment ratio (%) of Finland in 1993 and the Gross enrolment ratio (%) of Slovak Republic in 1995?
Offer a very short reply. -37.85. What is the difference between the Gross enrolment ratio (%) of Caribbean small states in 1993 and the Gross enrolment ratio (%) of Bulgaria in 1996?
Provide a short and direct response. 0.82. What is the difference between the Gross enrolment ratio (%) in Caribbean small states in 1993 and the Gross enrolment ratio (%) in Finland in 1996?
Make the answer very short. 24.58. What is the difference between the Gross enrolment ratio (%) in Caribbean small states in 1993 and the Gross enrolment ratio (%) in Slovak Republic in 1996?
Offer a very short reply. -4.67. What is the difference between the Gross enrolment ratio (%) in Bulgaria in 1993 and the Gross enrolment ratio (%) in Finland in 1996?
Your answer should be very brief. 19.04. What is the difference between the Gross enrolment ratio (%) in Bulgaria in 1993 and the Gross enrolment ratio (%) in Slovak Republic in 1996?
Offer a very short reply. -10.21. What is the difference between the Gross enrolment ratio (%) in Finland in 1993 and the Gross enrolment ratio (%) in Slovak Republic in 1996?
Ensure brevity in your answer.  -35.28. What is the difference between the Gross enrolment ratio (%) in Caribbean small states in 1993 and the Gross enrolment ratio (%) in Bulgaria in 1997?
Your answer should be very brief. -1.03. What is the difference between the Gross enrolment ratio (%) in Caribbean small states in 1993 and the Gross enrolment ratio (%) in Finland in 1997?
Make the answer very short. 21.22. What is the difference between the Gross enrolment ratio (%) of Caribbean small states in 1993 and the Gross enrolment ratio (%) of Slovak Republic in 1997?
Keep it short and to the point. -9.51. What is the difference between the Gross enrolment ratio (%) of Bulgaria in 1993 and the Gross enrolment ratio (%) of Finland in 1997?
Offer a very short reply. 15.69. What is the difference between the Gross enrolment ratio (%) of Bulgaria in 1993 and the Gross enrolment ratio (%) of Slovak Republic in 1997?
Keep it short and to the point. -15.05. What is the difference between the Gross enrolment ratio (%) of Finland in 1993 and the Gross enrolment ratio (%) of Slovak Republic in 1997?
Your answer should be very brief. -40.12. What is the difference between the Gross enrolment ratio (%) of Caribbean small states in 1993 and the Gross enrolment ratio (%) of Bulgaria in 1998?
Make the answer very short. 2.01. What is the difference between the Gross enrolment ratio (%) of Caribbean small states in 1993 and the Gross enrolment ratio (%) of Finland in 1998?
Make the answer very short. 20.36. What is the difference between the Gross enrolment ratio (%) in Caribbean small states in 1993 and the Gross enrolment ratio (%) in Slovak Republic in 1998?
Make the answer very short. -11.85. What is the difference between the Gross enrolment ratio (%) of Bulgaria in 1993 and the Gross enrolment ratio (%) of Finland in 1998?
Your answer should be compact. 14.83. What is the difference between the Gross enrolment ratio (%) of Bulgaria in 1993 and the Gross enrolment ratio (%) of Slovak Republic in 1998?
Ensure brevity in your answer.  -17.38. What is the difference between the Gross enrolment ratio (%) in Finland in 1993 and the Gross enrolment ratio (%) in Slovak Republic in 1998?
Keep it short and to the point. -42.46. What is the difference between the Gross enrolment ratio (%) in Caribbean small states in 1994 and the Gross enrolment ratio (%) in Bulgaria in 1995?
Your response must be concise. 8.08. What is the difference between the Gross enrolment ratio (%) in Caribbean small states in 1994 and the Gross enrolment ratio (%) in Finland in 1995?
Your response must be concise. 30.11. What is the difference between the Gross enrolment ratio (%) of Caribbean small states in 1994 and the Gross enrolment ratio (%) of Slovak Republic in 1995?
Your answer should be very brief. -4.88. What is the difference between the Gross enrolment ratio (%) of Bulgaria in 1994 and the Gross enrolment ratio (%) of Finland in 1995?
Your answer should be compact. 19.65. What is the difference between the Gross enrolment ratio (%) in Bulgaria in 1994 and the Gross enrolment ratio (%) in Slovak Republic in 1995?
Provide a short and direct response. -15.34. What is the difference between the Gross enrolment ratio (%) in Finland in 1994 and the Gross enrolment ratio (%) in Slovak Republic in 1995?
Provide a short and direct response. -36.52. What is the difference between the Gross enrolment ratio (%) of Caribbean small states in 1994 and the Gross enrolment ratio (%) of Bulgaria in 1996?
Make the answer very short. 3.18. What is the difference between the Gross enrolment ratio (%) of Caribbean small states in 1994 and the Gross enrolment ratio (%) of Finland in 1996?
Offer a very short reply. 26.94. What is the difference between the Gross enrolment ratio (%) in Caribbean small states in 1994 and the Gross enrolment ratio (%) in Slovak Republic in 1996?
Make the answer very short. -2.31. What is the difference between the Gross enrolment ratio (%) of Bulgaria in 1994 and the Gross enrolment ratio (%) of Finland in 1996?
Your answer should be very brief. 16.48. What is the difference between the Gross enrolment ratio (%) of Bulgaria in 1994 and the Gross enrolment ratio (%) of Slovak Republic in 1996?
Offer a terse response. -12.77. What is the difference between the Gross enrolment ratio (%) in Finland in 1994 and the Gross enrolment ratio (%) in Slovak Republic in 1996?
Make the answer very short. -33.96. What is the difference between the Gross enrolment ratio (%) in Caribbean small states in 1994 and the Gross enrolment ratio (%) in Bulgaria in 1997?
Give a very brief answer. 1.33. What is the difference between the Gross enrolment ratio (%) in Caribbean small states in 1994 and the Gross enrolment ratio (%) in Finland in 1997?
Provide a succinct answer. 23.58. What is the difference between the Gross enrolment ratio (%) of Caribbean small states in 1994 and the Gross enrolment ratio (%) of Slovak Republic in 1997?
Ensure brevity in your answer.  -7.15. What is the difference between the Gross enrolment ratio (%) in Bulgaria in 1994 and the Gross enrolment ratio (%) in Finland in 1997?
Give a very brief answer. 13.12. What is the difference between the Gross enrolment ratio (%) in Bulgaria in 1994 and the Gross enrolment ratio (%) in Slovak Republic in 1997?
Ensure brevity in your answer.  -17.61. What is the difference between the Gross enrolment ratio (%) of Finland in 1994 and the Gross enrolment ratio (%) of Slovak Republic in 1997?
Provide a succinct answer. -38.8. What is the difference between the Gross enrolment ratio (%) in Caribbean small states in 1994 and the Gross enrolment ratio (%) in Bulgaria in 1998?
Your answer should be very brief. 4.37. What is the difference between the Gross enrolment ratio (%) of Caribbean small states in 1994 and the Gross enrolment ratio (%) of Finland in 1998?
Provide a succinct answer. 22.72. What is the difference between the Gross enrolment ratio (%) of Caribbean small states in 1994 and the Gross enrolment ratio (%) of Slovak Republic in 1998?
Keep it short and to the point. -9.49. What is the difference between the Gross enrolment ratio (%) in Bulgaria in 1994 and the Gross enrolment ratio (%) in Finland in 1998?
Your answer should be very brief. 12.26. What is the difference between the Gross enrolment ratio (%) of Bulgaria in 1994 and the Gross enrolment ratio (%) of Slovak Republic in 1998?
Your answer should be very brief. -19.95. What is the difference between the Gross enrolment ratio (%) of Finland in 1994 and the Gross enrolment ratio (%) of Slovak Republic in 1998?
Offer a terse response. -41.13. What is the difference between the Gross enrolment ratio (%) in Caribbean small states in 1995 and the Gross enrolment ratio (%) in Bulgaria in 1996?
Keep it short and to the point. 4.11. What is the difference between the Gross enrolment ratio (%) in Caribbean small states in 1995 and the Gross enrolment ratio (%) in Finland in 1996?
Your answer should be compact. 27.87. What is the difference between the Gross enrolment ratio (%) of Caribbean small states in 1995 and the Gross enrolment ratio (%) of Slovak Republic in 1996?
Your response must be concise. -1.38. What is the difference between the Gross enrolment ratio (%) in Bulgaria in 1995 and the Gross enrolment ratio (%) in Finland in 1996?
Your answer should be very brief. 18.86. What is the difference between the Gross enrolment ratio (%) in Bulgaria in 1995 and the Gross enrolment ratio (%) in Slovak Republic in 1996?
Make the answer very short. -10.39. What is the difference between the Gross enrolment ratio (%) in Finland in 1995 and the Gross enrolment ratio (%) in Slovak Republic in 1996?
Give a very brief answer. -32.42. What is the difference between the Gross enrolment ratio (%) of Caribbean small states in 1995 and the Gross enrolment ratio (%) of Bulgaria in 1997?
Offer a very short reply. 2.26. What is the difference between the Gross enrolment ratio (%) in Caribbean small states in 1995 and the Gross enrolment ratio (%) in Finland in 1997?
Your answer should be very brief. 24.52. What is the difference between the Gross enrolment ratio (%) in Caribbean small states in 1995 and the Gross enrolment ratio (%) in Slovak Republic in 1997?
Provide a short and direct response. -6.22. What is the difference between the Gross enrolment ratio (%) in Bulgaria in 1995 and the Gross enrolment ratio (%) in Finland in 1997?
Keep it short and to the point. 15.5. What is the difference between the Gross enrolment ratio (%) of Bulgaria in 1995 and the Gross enrolment ratio (%) of Slovak Republic in 1997?
Your answer should be compact. -15.23. What is the difference between the Gross enrolment ratio (%) in Finland in 1995 and the Gross enrolment ratio (%) in Slovak Republic in 1997?
Ensure brevity in your answer.  -37.26. What is the difference between the Gross enrolment ratio (%) of Caribbean small states in 1995 and the Gross enrolment ratio (%) of Bulgaria in 1998?
Offer a very short reply. 5.31. What is the difference between the Gross enrolment ratio (%) of Caribbean small states in 1995 and the Gross enrolment ratio (%) of Finland in 1998?
Make the answer very short. 23.65. What is the difference between the Gross enrolment ratio (%) in Caribbean small states in 1995 and the Gross enrolment ratio (%) in Slovak Republic in 1998?
Keep it short and to the point. -8.55. What is the difference between the Gross enrolment ratio (%) of Bulgaria in 1995 and the Gross enrolment ratio (%) of Finland in 1998?
Your response must be concise. 14.64. What is the difference between the Gross enrolment ratio (%) of Bulgaria in 1995 and the Gross enrolment ratio (%) of Slovak Republic in 1998?
Your answer should be compact. -17.57. What is the difference between the Gross enrolment ratio (%) of Finland in 1995 and the Gross enrolment ratio (%) of Slovak Republic in 1998?
Make the answer very short. -39.6. What is the difference between the Gross enrolment ratio (%) of Caribbean small states in 1996 and the Gross enrolment ratio (%) of Bulgaria in 1997?
Offer a very short reply. 3.78. What is the difference between the Gross enrolment ratio (%) of Caribbean small states in 1996 and the Gross enrolment ratio (%) of Finland in 1997?
Keep it short and to the point. 26.03. What is the difference between the Gross enrolment ratio (%) of Caribbean small states in 1996 and the Gross enrolment ratio (%) of Slovak Republic in 1997?
Provide a succinct answer. -4.7. What is the difference between the Gross enrolment ratio (%) in Bulgaria in 1996 and the Gross enrolment ratio (%) in Finland in 1997?
Your answer should be compact. 20.41. What is the difference between the Gross enrolment ratio (%) in Bulgaria in 1996 and the Gross enrolment ratio (%) in Slovak Republic in 1997?
Keep it short and to the point. -10.33. What is the difference between the Gross enrolment ratio (%) of Finland in 1996 and the Gross enrolment ratio (%) of Slovak Republic in 1997?
Give a very brief answer. -34.09. What is the difference between the Gross enrolment ratio (%) of Caribbean small states in 1996 and the Gross enrolment ratio (%) of Bulgaria in 1998?
Provide a short and direct response. 6.82. What is the difference between the Gross enrolment ratio (%) of Caribbean small states in 1996 and the Gross enrolment ratio (%) of Finland in 1998?
Your answer should be compact. 25.17. What is the difference between the Gross enrolment ratio (%) in Caribbean small states in 1996 and the Gross enrolment ratio (%) in Slovak Republic in 1998?
Your answer should be compact. -7.04. What is the difference between the Gross enrolment ratio (%) of Bulgaria in 1996 and the Gross enrolment ratio (%) of Finland in 1998?
Your answer should be very brief. 19.54. What is the difference between the Gross enrolment ratio (%) in Bulgaria in 1996 and the Gross enrolment ratio (%) in Slovak Republic in 1998?
Your response must be concise. -12.66. What is the difference between the Gross enrolment ratio (%) of Finland in 1996 and the Gross enrolment ratio (%) of Slovak Republic in 1998?
Make the answer very short. -36.43. What is the difference between the Gross enrolment ratio (%) of Caribbean small states in 1997 and the Gross enrolment ratio (%) of Bulgaria in 1998?
Keep it short and to the point. 7.54. What is the difference between the Gross enrolment ratio (%) in Caribbean small states in 1997 and the Gross enrolment ratio (%) in Finland in 1998?
Keep it short and to the point. 25.88. What is the difference between the Gross enrolment ratio (%) in Caribbean small states in 1997 and the Gross enrolment ratio (%) in Slovak Republic in 1998?
Make the answer very short. -6.32. What is the difference between the Gross enrolment ratio (%) in Bulgaria in 1997 and the Gross enrolment ratio (%) in Finland in 1998?
Offer a very short reply. 21.39. What is the difference between the Gross enrolment ratio (%) in Bulgaria in 1997 and the Gross enrolment ratio (%) in Slovak Republic in 1998?
Your response must be concise. -10.82. What is the difference between the Gross enrolment ratio (%) in Finland in 1997 and the Gross enrolment ratio (%) in Slovak Republic in 1998?
Provide a succinct answer. -33.07. What is the average Gross enrolment ratio (%) of Caribbean small states per year?
Provide a succinct answer. 68.03. What is the average Gross enrolment ratio (%) in Bulgaria per year?
Your response must be concise. 62.91. What is the average Gross enrolment ratio (%) of Finland per year?
Make the answer very short. 39. What is the average Gross enrolment ratio (%) in Slovak Republic per year?
Give a very brief answer. 76.43. In the year 1991, what is the difference between the Gross enrolment ratio (%) in Caribbean small states and Gross enrolment ratio (%) in Bulgaria?
Your answer should be very brief. -6.91. In the year 1991, what is the difference between the Gross enrolment ratio (%) of Caribbean small states and Gross enrolment ratio (%) of Finland?
Provide a succinct answer. 27.49. In the year 1991, what is the difference between the Gross enrolment ratio (%) of Caribbean small states and Gross enrolment ratio (%) of Slovak Republic?
Provide a short and direct response. -24.44. In the year 1991, what is the difference between the Gross enrolment ratio (%) in Bulgaria and Gross enrolment ratio (%) in Finland?
Ensure brevity in your answer.  34.4. In the year 1991, what is the difference between the Gross enrolment ratio (%) in Bulgaria and Gross enrolment ratio (%) in Slovak Republic?
Give a very brief answer. -17.53. In the year 1991, what is the difference between the Gross enrolment ratio (%) in Finland and Gross enrolment ratio (%) in Slovak Republic?
Ensure brevity in your answer.  -51.92. In the year 1992, what is the difference between the Gross enrolment ratio (%) of Caribbean small states and Gross enrolment ratio (%) of Bulgaria?
Make the answer very short. 4.18. In the year 1992, what is the difference between the Gross enrolment ratio (%) in Caribbean small states and Gross enrolment ratio (%) in Finland?
Your answer should be very brief. 28.37. In the year 1992, what is the difference between the Gross enrolment ratio (%) in Caribbean small states and Gross enrolment ratio (%) in Slovak Republic?
Provide a succinct answer. -12.69. In the year 1992, what is the difference between the Gross enrolment ratio (%) of Bulgaria and Gross enrolment ratio (%) of Finland?
Provide a succinct answer. 24.19. In the year 1992, what is the difference between the Gross enrolment ratio (%) of Bulgaria and Gross enrolment ratio (%) of Slovak Republic?
Offer a very short reply. -16.87. In the year 1992, what is the difference between the Gross enrolment ratio (%) in Finland and Gross enrolment ratio (%) in Slovak Republic?
Offer a very short reply. -41.06. In the year 1993, what is the difference between the Gross enrolment ratio (%) in Caribbean small states and Gross enrolment ratio (%) in Bulgaria?
Your response must be concise. 5.54. In the year 1993, what is the difference between the Gross enrolment ratio (%) of Caribbean small states and Gross enrolment ratio (%) of Finland?
Offer a terse response. 30.61. In the year 1993, what is the difference between the Gross enrolment ratio (%) of Caribbean small states and Gross enrolment ratio (%) of Slovak Republic?
Make the answer very short. -10.13. In the year 1993, what is the difference between the Gross enrolment ratio (%) in Bulgaria and Gross enrolment ratio (%) in Finland?
Offer a very short reply. 25.08. In the year 1993, what is the difference between the Gross enrolment ratio (%) in Bulgaria and Gross enrolment ratio (%) in Slovak Republic?
Your answer should be compact. -15.66. In the year 1993, what is the difference between the Gross enrolment ratio (%) of Finland and Gross enrolment ratio (%) of Slovak Republic?
Make the answer very short. -40.74. In the year 1994, what is the difference between the Gross enrolment ratio (%) in Caribbean small states and Gross enrolment ratio (%) in Bulgaria?
Keep it short and to the point. 10.46. In the year 1994, what is the difference between the Gross enrolment ratio (%) in Caribbean small states and Gross enrolment ratio (%) in Finland?
Keep it short and to the point. 31.65. In the year 1994, what is the difference between the Gross enrolment ratio (%) of Caribbean small states and Gross enrolment ratio (%) of Slovak Republic?
Give a very brief answer. -6.84. In the year 1994, what is the difference between the Gross enrolment ratio (%) of Bulgaria and Gross enrolment ratio (%) of Finland?
Provide a short and direct response. 21.19. In the year 1994, what is the difference between the Gross enrolment ratio (%) of Bulgaria and Gross enrolment ratio (%) of Slovak Republic?
Your response must be concise. -17.3. In the year 1994, what is the difference between the Gross enrolment ratio (%) in Finland and Gross enrolment ratio (%) in Slovak Republic?
Make the answer very short. -38.49. In the year 1995, what is the difference between the Gross enrolment ratio (%) in Caribbean small states and Gross enrolment ratio (%) in Bulgaria?
Your answer should be very brief. 9.01. In the year 1995, what is the difference between the Gross enrolment ratio (%) in Caribbean small states and Gross enrolment ratio (%) in Finland?
Your response must be concise. 31.04. In the year 1995, what is the difference between the Gross enrolment ratio (%) in Caribbean small states and Gross enrolment ratio (%) in Slovak Republic?
Provide a succinct answer. -3.94. In the year 1995, what is the difference between the Gross enrolment ratio (%) in Bulgaria and Gross enrolment ratio (%) in Finland?
Your response must be concise. 22.03. In the year 1995, what is the difference between the Gross enrolment ratio (%) of Bulgaria and Gross enrolment ratio (%) of Slovak Republic?
Provide a succinct answer. -12.95. In the year 1995, what is the difference between the Gross enrolment ratio (%) of Finland and Gross enrolment ratio (%) of Slovak Republic?
Keep it short and to the point. -34.99. In the year 1996, what is the difference between the Gross enrolment ratio (%) in Caribbean small states and Gross enrolment ratio (%) in Bulgaria?
Keep it short and to the point. 5.62. In the year 1996, what is the difference between the Gross enrolment ratio (%) in Caribbean small states and Gross enrolment ratio (%) in Finland?
Your answer should be compact. 29.39. In the year 1996, what is the difference between the Gross enrolment ratio (%) in Caribbean small states and Gross enrolment ratio (%) in Slovak Republic?
Offer a terse response. 0.14. In the year 1996, what is the difference between the Gross enrolment ratio (%) of Bulgaria and Gross enrolment ratio (%) of Finland?
Provide a succinct answer. 23.76. In the year 1996, what is the difference between the Gross enrolment ratio (%) in Bulgaria and Gross enrolment ratio (%) in Slovak Republic?
Your answer should be very brief. -5.49. In the year 1996, what is the difference between the Gross enrolment ratio (%) in Finland and Gross enrolment ratio (%) in Slovak Republic?
Your response must be concise. -29.25. In the year 1997, what is the difference between the Gross enrolment ratio (%) of Caribbean small states and Gross enrolment ratio (%) of Bulgaria?
Your answer should be compact. 4.49. In the year 1997, what is the difference between the Gross enrolment ratio (%) of Caribbean small states and Gross enrolment ratio (%) of Finland?
Ensure brevity in your answer.  26.75. In the year 1997, what is the difference between the Gross enrolment ratio (%) in Caribbean small states and Gross enrolment ratio (%) in Slovak Republic?
Your response must be concise. -3.99. In the year 1997, what is the difference between the Gross enrolment ratio (%) in Bulgaria and Gross enrolment ratio (%) in Finland?
Give a very brief answer. 22.25. In the year 1997, what is the difference between the Gross enrolment ratio (%) of Bulgaria and Gross enrolment ratio (%) of Slovak Republic?
Give a very brief answer. -8.48. In the year 1997, what is the difference between the Gross enrolment ratio (%) in Finland and Gross enrolment ratio (%) in Slovak Republic?
Your response must be concise. -30.73. In the year 1998, what is the difference between the Gross enrolment ratio (%) in Caribbean small states and Gross enrolment ratio (%) in Bulgaria?
Make the answer very short. 8.6. In the year 1998, what is the difference between the Gross enrolment ratio (%) of Caribbean small states and Gross enrolment ratio (%) of Finland?
Offer a very short reply. 26.95. In the year 1998, what is the difference between the Gross enrolment ratio (%) of Caribbean small states and Gross enrolment ratio (%) of Slovak Republic?
Make the answer very short. -5.26. In the year 1998, what is the difference between the Gross enrolment ratio (%) of Bulgaria and Gross enrolment ratio (%) of Finland?
Offer a terse response. 18.35. In the year 1998, what is the difference between the Gross enrolment ratio (%) in Bulgaria and Gross enrolment ratio (%) in Slovak Republic?
Provide a succinct answer. -13.86. In the year 1998, what is the difference between the Gross enrolment ratio (%) of Finland and Gross enrolment ratio (%) of Slovak Republic?
Ensure brevity in your answer.  -32.21. What is the ratio of the Gross enrolment ratio (%) in Caribbean small states in 1991 to that in 1992?
Offer a terse response. 0.97. What is the ratio of the Gross enrolment ratio (%) in Bulgaria in 1991 to that in 1992?
Keep it short and to the point. 1.15. What is the ratio of the Gross enrolment ratio (%) of Finland in 1991 to that in 1992?
Ensure brevity in your answer.  0.97. What is the ratio of the Gross enrolment ratio (%) in Slovak Republic in 1991 to that in 1992?
Provide a short and direct response. 1.13. What is the ratio of the Gross enrolment ratio (%) of Caribbean small states in 1991 to that in 1993?
Provide a short and direct response. 0.92. What is the ratio of the Gross enrolment ratio (%) in Bulgaria in 1991 to that in 1993?
Provide a short and direct response. 1.12. What is the ratio of the Gross enrolment ratio (%) of Finland in 1991 to that in 1993?
Your answer should be very brief. 0.94. What is the ratio of the Gross enrolment ratio (%) of Slovak Republic in 1991 to that in 1993?
Keep it short and to the point. 1.12. What is the ratio of the Gross enrolment ratio (%) in Caribbean small states in 1991 to that in 1994?
Provide a short and direct response. 0.89. What is the ratio of the Gross enrolment ratio (%) of Bulgaria in 1991 to that in 1994?
Provide a short and direct response. 1.17. What is the ratio of the Gross enrolment ratio (%) in Finland in 1991 to that in 1994?
Your answer should be compact. 0.91. What is the ratio of the Gross enrolment ratio (%) of Slovak Republic in 1991 to that in 1994?
Your response must be concise. 1.13. What is the ratio of the Gross enrolment ratio (%) in Caribbean small states in 1991 to that in 1995?
Ensure brevity in your answer.  0.88. What is the ratio of the Gross enrolment ratio (%) of Bulgaria in 1991 to that in 1995?
Offer a terse response. 1.12. What is the ratio of the Gross enrolment ratio (%) in Finland in 1991 to that in 1995?
Offer a terse response. 0.87. What is the ratio of the Gross enrolment ratio (%) in Slovak Republic in 1991 to that in 1995?
Make the answer very short. 1.16. What is the ratio of the Gross enrolment ratio (%) of Caribbean small states in 1991 to that in 1996?
Ensure brevity in your answer.  0.86. What is the ratio of the Gross enrolment ratio (%) in Bulgaria in 1991 to that in 1996?
Provide a succinct answer. 1.04. What is the ratio of the Gross enrolment ratio (%) of Finland in 1991 to that in 1996?
Your answer should be very brief. 0.81. What is the ratio of the Gross enrolment ratio (%) in Slovak Republic in 1991 to that in 1996?
Ensure brevity in your answer.  1.21. What is the ratio of the Gross enrolment ratio (%) in Caribbean small states in 1991 to that in 1997?
Offer a terse response. 0.85. What is the ratio of the Gross enrolment ratio (%) of Bulgaria in 1991 to that in 1997?
Your response must be concise. 1.01. What is the ratio of the Gross enrolment ratio (%) in Finland in 1991 to that in 1997?
Your response must be concise. 0.75. What is the ratio of the Gross enrolment ratio (%) of Slovak Republic in 1991 to that in 1997?
Ensure brevity in your answer.  1.13. What is the ratio of the Gross enrolment ratio (%) of Caribbean small states in 1991 to that in 1998?
Your response must be concise. 0.84. What is the ratio of the Gross enrolment ratio (%) of Bulgaria in 1991 to that in 1998?
Ensure brevity in your answer.  1.06. What is the ratio of the Gross enrolment ratio (%) of Finland in 1991 to that in 1998?
Provide a succinct answer. 0.73. What is the ratio of the Gross enrolment ratio (%) in Slovak Republic in 1991 to that in 1998?
Keep it short and to the point. 1.1. What is the ratio of the Gross enrolment ratio (%) of Caribbean small states in 1992 to that in 1993?
Ensure brevity in your answer.  0.95. What is the ratio of the Gross enrolment ratio (%) of Bulgaria in 1992 to that in 1993?
Give a very brief answer. 0.97. What is the ratio of the Gross enrolment ratio (%) in Finland in 1992 to that in 1993?
Ensure brevity in your answer.  0.98. What is the ratio of the Gross enrolment ratio (%) in Slovak Republic in 1992 to that in 1993?
Keep it short and to the point. 0.99. What is the ratio of the Gross enrolment ratio (%) in Caribbean small states in 1992 to that in 1994?
Offer a terse response. 0.92. What is the ratio of the Gross enrolment ratio (%) of Bulgaria in 1992 to that in 1994?
Provide a short and direct response. 1.01. What is the ratio of the Gross enrolment ratio (%) in Finland in 1992 to that in 1994?
Provide a short and direct response. 0.94. What is the ratio of the Gross enrolment ratio (%) in Caribbean small states in 1992 to that in 1995?
Make the answer very short. 0.91. What is the ratio of the Gross enrolment ratio (%) of Bulgaria in 1992 to that in 1995?
Give a very brief answer. 0.97. What is the ratio of the Gross enrolment ratio (%) of Finland in 1992 to that in 1995?
Provide a short and direct response. 0.9. What is the ratio of the Gross enrolment ratio (%) in Slovak Republic in 1992 to that in 1995?
Your answer should be compact. 1.03. What is the ratio of the Gross enrolment ratio (%) of Caribbean small states in 1992 to that in 1996?
Provide a succinct answer. 0.89. What is the ratio of the Gross enrolment ratio (%) in Bulgaria in 1992 to that in 1996?
Your response must be concise. 0.9. What is the ratio of the Gross enrolment ratio (%) in Finland in 1992 to that in 1996?
Offer a terse response. 0.83. What is the ratio of the Gross enrolment ratio (%) of Slovak Republic in 1992 to that in 1996?
Your answer should be very brief. 1.07. What is the ratio of the Gross enrolment ratio (%) in Bulgaria in 1992 to that in 1997?
Give a very brief answer. 0.88. What is the ratio of the Gross enrolment ratio (%) in Finland in 1992 to that in 1997?
Offer a very short reply. 0.77. What is the ratio of the Gross enrolment ratio (%) in Caribbean small states in 1992 to that in 1998?
Give a very brief answer. 0.87. What is the ratio of the Gross enrolment ratio (%) of Bulgaria in 1992 to that in 1998?
Make the answer very short. 0.92. What is the ratio of the Gross enrolment ratio (%) in Finland in 1992 to that in 1998?
Offer a terse response. 0.76. What is the ratio of the Gross enrolment ratio (%) in Slovak Republic in 1992 to that in 1998?
Offer a very short reply. 0.97. What is the ratio of the Gross enrolment ratio (%) in Caribbean small states in 1993 to that in 1994?
Your answer should be compact. 0.97. What is the ratio of the Gross enrolment ratio (%) of Bulgaria in 1993 to that in 1994?
Provide a succinct answer. 1.04. What is the ratio of the Gross enrolment ratio (%) of Finland in 1993 to that in 1994?
Your answer should be very brief. 0.96. What is the ratio of the Gross enrolment ratio (%) of Slovak Republic in 1993 to that in 1994?
Make the answer very short. 1.01. What is the ratio of the Gross enrolment ratio (%) of Caribbean small states in 1993 to that in 1995?
Provide a succinct answer. 0.95. What is the ratio of the Gross enrolment ratio (%) of Finland in 1993 to that in 1995?
Ensure brevity in your answer.  0.93. What is the ratio of the Gross enrolment ratio (%) in Slovak Republic in 1993 to that in 1995?
Offer a very short reply. 1.04. What is the ratio of the Gross enrolment ratio (%) of Caribbean small states in 1993 to that in 1996?
Ensure brevity in your answer.  0.93. What is the ratio of the Gross enrolment ratio (%) of Bulgaria in 1993 to that in 1996?
Your response must be concise. 0.93. What is the ratio of the Gross enrolment ratio (%) in Finland in 1993 to that in 1996?
Your answer should be very brief. 0.86. What is the ratio of the Gross enrolment ratio (%) in Slovak Republic in 1993 to that in 1996?
Ensure brevity in your answer.  1.08. What is the ratio of the Gross enrolment ratio (%) of Bulgaria in 1993 to that in 1997?
Your answer should be very brief. 0.9. What is the ratio of the Gross enrolment ratio (%) in Finland in 1993 to that in 1997?
Offer a terse response. 0.79. What is the ratio of the Gross enrolment ratio (%) of Caribbean small states in 1993 to that in 1998?
Your response must be concise. 0.91. What is the ratio of the Gross enrolment ratio (%) of Bulgaria in 1993 to that in 1998?
Make the answer very short. 0.95. What is the ratio of the Gross enrolment ratio (%) of Finland in 1993 to that in 1998?
Your response must be concise. 0.78. What is the ratio of the Gross enrolment ratio (%) of Caribbean small states in 1994 to that in 1995?
Your response must be concise. 0.99. What is the ratio of the Gross enrolment ratio (%) in Bulgaria in 1994 to that in 1995?
Keep it short and to the point. 0.96. What is the ratio of the Gross enrolment ratio (%) in Finland in 1994 to that in 1995?
Your answer should be very brief. 0.96. What is the ratio of the Gross enrolment ratio (%) of Slovak Republic in 1994 to that in 1995?
Offer a very short reply. 1.03. What is the ratio of the Gross enrolment ratio (%) of Caribbean small states in 1994 to that in 1996?
Your answer should be very brief. 0.97. What is the ratio of the Gross enrolment ratio (%) in Bulgaria in 1994 to that in 1996?
Your response must be concise. 0.89. What is the ratio of the Gross enrolment ratio (%) of Finland in 1994 to that in 1996?
Keep it short and to the point. 0.89. What is the ratio of the Gross enrolment ratio (%) in Slovak Republic in 1994 to that in 1996?
Your answer should be very brief. 1.06. What is the ratio of the Gross enrolment ratio (%) in Caribbean small states in 1994 to that in 1997?
Keep it short and to the point. 0.96. What is the ratio of the Gross enrolment ratio (%) in Bulgaria in 1994 to that in 1997?
Offer a terse response. 0.86. What is the ratio of the Gross enrolment ratio (%) of Finland in 1994 to that in 1997?
Give a very brief answer. 0.82. What is the ratio of the Gross enrolment ratio (%) of Caribbean small states in 1994 to that in 1998?
Provide a succinct answer. 0.94. What is the ratio of the Gross enrolment ratio (%) in Bulgaria in 1994 to that in 1998?
Offer a terse response. 0.91. What is the ratio of the Gross enrolment ratio (%) in Finland in 1994 to that in 1998?
Your answer should be very brief. 0.81. What is the ratio of the Gross enrolment ratio (%) in Slovak Republic in 1994 to that in 1998?
Give a very brief answer. 0.97. What is the ratio of the Gross enrolment ratio (%) in Caribbean small states in 1995 to that in 1996?
Your answer should be very brief. 0.98. What is the ratio of the Gross enrolment ratio (%) of Bulgaria in 1995 to that in 1996?
Offer a terse response. 0.93. What is the ratio of the Gross enrolment ratio (%) of Finland in 1995 to that in 1996?
Keep it short and to the point. 0.92. What is the ratio of the Gross enrolment ratio (%) of Slovak Republic in 1995 to that in 1996?
Your answer should be compact. 1.04. What is the ratio of the Gross enrolment ratio (%) in Caribbean small states in 1995 to that in 1997?
Keep it short and to the point. 0.97. What is the ratio of the Gross enrolment ratio (%) in Bulgaria in 1995 to that in 1997?
Give a very brief answer. 0.9. What is the ratio of the Gross enrolment ratio (%) of Finland in 1995 to that in 1997?
Ensure brevity in your answer.  0.85. What is the ratio of the Gross enrolment ratio (%) in Slovak Republic in 1995 to that in 1997?
Your answer should be very brief. 0.97. What is the ratio of the Gross enrolment ratio (%) of Caribbean small states in 1995 to that in 1998?
Give a very brief answer. 0.95. What is the ratio of the Gross enrolment ratio (%) in Bulgaria in 1995 to that in 1998?
Provide a succinct answer. 0.94. What is the ratio of the Gross enrolment ratio (%) of Finland in 1995 to that in 1998?
Offer a very short reply. 0.84. What is the ratio of the Gross enrolment ratio (%) of Slovak Republic in 1995 to that in 1998?
Your response must be concise. 0.94. What is the ratio of the Gross enrolment ratio (%) in Caribbean small states in 1996 to that in 1997?
Provide a succinct answer. 0.99. What is the ratio of the Gross enrolment ratio (%) in Bulgaria in 1996 to that in 1997?
Your answer should be compact. 0.97. What is the ratio of the Gross enrolment ratio (%) in Finland in 1996 to that in 1997?
Your response must be concise. 0.93. What is the ratio of the Gross enrolment ratio (%) of Slovak Republic in 1996 to that in 1997?
Provide a short and direct response. 0.94. What is the ratio of the Gross enrolment ratio (%) in Caribbean small states in 1996 to that in 1998?
Your answer should be very brief. 0.98. What is the ratio of the Gross enrolment ratio (%) in Bulgaria in 1996 to that in 1998?
Provide a short and direct response. 1.02. What is the ratio of the Gross enrolment ratio (%) in Finland in 1996 to that in 1998?
Your answer should be compact. 0.91. What is the ratio of the Gross enrolment ratio (%) in Slovak Republic in 1996 to that in 1998?
Offer a terse response. 0.91. What is the ratio of the Gross enrolment ratio (%) of Caribbean small states in 1997 to that in 1998?
Ensure brevity in your answer.  0.99. What is the ratio of the Gross enrolment ratio (%) in Bulgaria in 1997 to that in 1998?
Offer a very short reply. 1.05. What is the ratio of the Gross enrolment ratio (%) in Finland in 1997 to that in 1998?
Your response must be concise. 0.98. What is the ratio of the Gross enrolment ratio (%) of Slovak Republic in 1997 to that in 1998?
Offer a very short reply. 0.97. What is the difference between the highest and the second highest Gross enrolment ratio (%) in Caribbean small states?
Provide a short and direct response. 1.07. What is the difference between the highest and the second highest Gross enrolment ratio (%) of Bulgaria?
Your response must be concise. 0.76. What is the difference between the highest and the second highest Gross enrolment ratio (%) of Finland?
Your answer should be very brief. 0.86. What is the difference between the highest and the second highest Gross enrolment ratio (%) in Slovak Republic?
Provide a succinct answer. 7.47. What is the difference between the highest and the lowest Gross enrolment ratio (%) in Caribbean small states?
Your response must be concise. 11.71. What is the difference between the highest and the lowest Gross enrolment ratio (%) in Bulgaria?
Provide a short and direct response. 9.89. What is the difference between the highest and the lowest Gross enrolment ratio (%) in Finland?
Give a very brief answer. 12.25. What is the difference between the highest and the lowest Gross enrolment ratio (%) of Slovak Republic?
Offer a terse response. 14.64. 